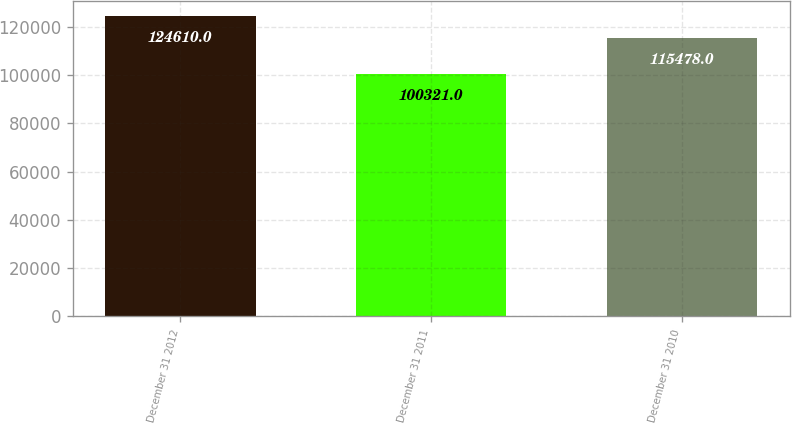<chart> <loc_0><loc_0><loc_500><loc_500><bar_chart><fcel>December 31 2012<fcel>December 31 2011<fcel>December 31 2010<nl><fcel>124610<fcel>100321<fcel>115478<nl></chart> 